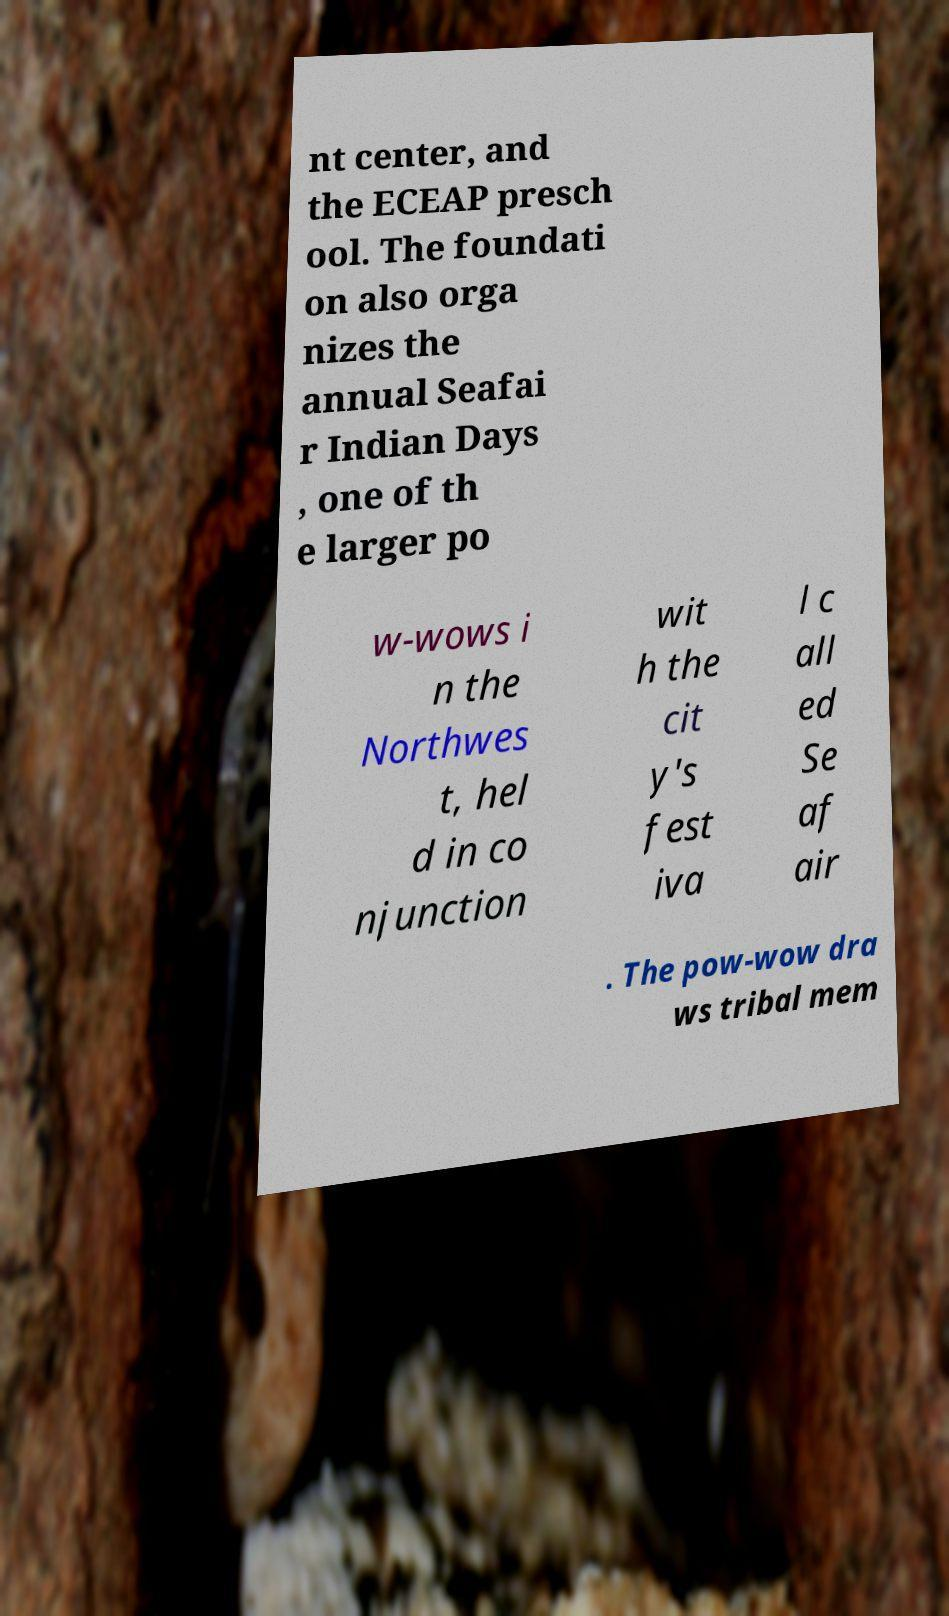There's text embedded in this image that I need extracted. Can you transcribe it verbatim? nt center, and the ECEAP presch ool. The foundati on also orga nizes the annual Seafai r Indian Days , one of th e larger po w-wows i n the Northwes t, hel d in co njunction wit h the cit y's fest iva l c all ed Se af air . The pow-wow dra ws tribal mem 